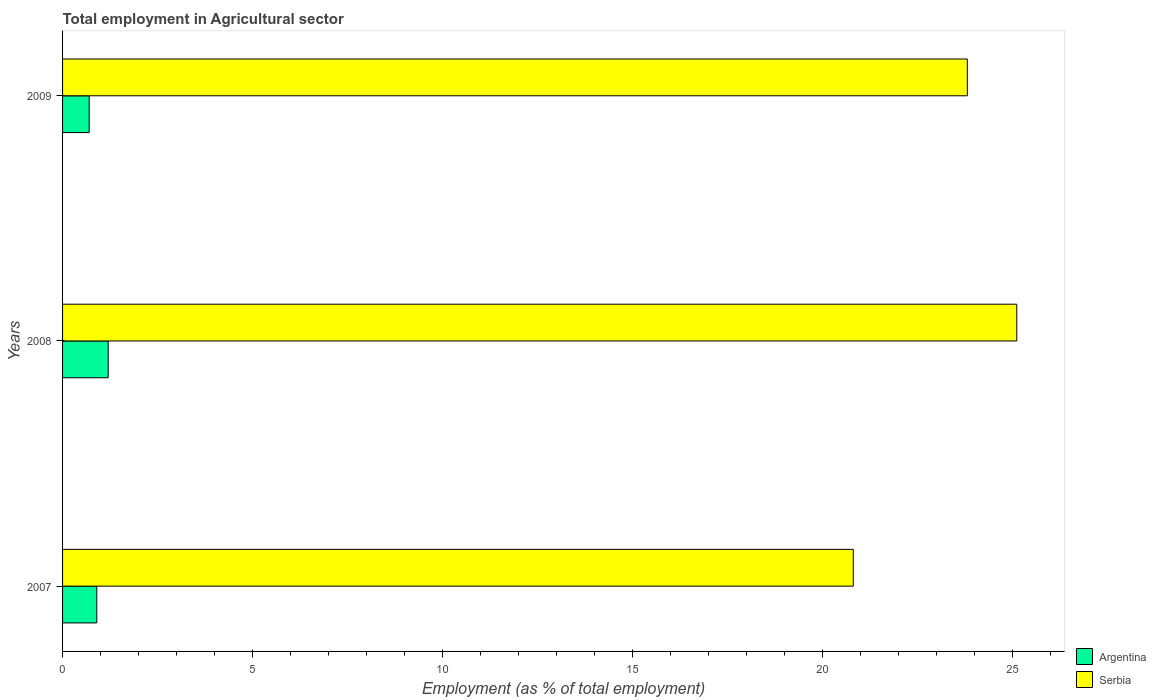How many different coloured bars are there?
Provide a short and direct response. 2. How many groups of bars are there?
Your answer should be compact. 3. How many bars are there on the 1st tick from the top?
Offer a very short reply. 2. How many bars are there on the 1st tick from the bottom?
Your response must be concise. 2. In how many cases, is the number of bars for a given year not equal to the number of legend labels?
Provide a succinct answer. 0. What is the employment in agricultural sector in Argentina in 2009?
Provide a short and direct response. 0.7. Across all years, what is the maximum employment in agricultural sector in Serbia?
Your answer should be compact. 25.1. Across all years, what is the minimum employment in agricultural sector in Argentina?
Provide a succinct answer. 0.7. In which year was the employment in agricultural sector in Argentina maximum?
Your answer should be very brief. 2008. What is the total employment in agricultural sector in Argentina in the graph?
Make the answer very short. 2.8. What is the difference between the employment in agricultural sector in Serbia in 2008 and that in 2009?
Give a very brief answer. 1.3. What is the difference between the employment in agricultural sector in Serbia in 2008 and the employment in agricultural sector in Argentina in 2007?
Offer a terse response. 24.2. What is the average employment in agricultural sector in Argentina per year?
Keep it short and to the point. 0.93. In the year 2007, what is the difference between the employment in agricultural sector in Serbia and employment in agricultural sector in Argentina?
Your answer should be very brief. 19.9. In how many years, is the employment in agricultural sector in Serbia greater than 6 %?
Provide a succinct answer. 3. What is the ratio of the employment in agricultural sector in Argentina in 2008 to that in 2009?
Your response must be concise. 1.71. Is the employment in agricultural sector in Serbia in 2007 less than that in 2009?
Your answer should be very brief. Yes. What is the difference between the highest and the second highest employment in agricultural sector in Argentina?
Your answer should be very brief. 0.3. What is the difference between the highest and the lowest employment in agricultural sector in Argentina?
Your answer should be very brief. 0.5. Is the sum of the employment in agricultural sector in Serbia in 2007 and 2009 greater than the maximum employment in agricultural sector in Argentina across all years?
Offer a very short reply. Yes. What does the 1st bar from the top in 2008 represents?
Give a very brief answer. Serbia. What does the 1st bar from the bottom in 2007 represents?
Make the answer very short. Argentina. How many years are there in the graph?
Your answer should be very brief. 3. What is the difference between two consecutive major ticks on the X-axis?
Your answer should be very brief. 5. Does the graph contain grids?
Provide a succinct answer. No. What is the title of the graph?
Give a very brief answer. Total employment in Agricultural sector. Does "Finland" appear as one of the legend labels in the graph?
Provide a short and direct response. No. What is the label or title of the X-axis?
Provide a succinct answer. Employment (as % of total employment). What is the Employment (as % of total employment) in Argentina in 2007?
Make the answer very short. 0.9. What is the Employment (as % of total employment) of Serbia in 2007?
Keep it short and to the point. 20.8. What is the Employment (as % of total employment) of Argentina in 2008?
Keep it short and to the point. 1.2. What is the Employment (as % of total employment) of Serbia in 2008?
Provide a succinct answer. 25.1. What is the Employment (as % of total employment) in Argentina in 2009?
Offer a terse response. 0.7. What is the Employment (as % of total employment) of Serbia in 2009?
Offer a very short reply. 23.8. Across all years, what is the maximum Employment (as % of total employment) of Argentina?
Make the answer very short. 1.2. Across all years, what is the maximum Employment (as % of total employment) of Serbia?
Give a very brief answer. 25.1. Across all years, what is the minimum Employment (as % of total employment) of Argentina?
Ensure brevity in your answer.  0.7. Across all years, what is the minimum Employment (as % of total employment) of Serbia?
Give a very brief answer. 20.8. What is the total Employment (as % of total employment) in Argentina in the graph?
Keep it short and to the point. 2.8. What is the total Employment (as % of total employment) in Serbia in the graph?
Ensure brevity in your answer.  69.7. What is the difference between the Employment (as % of total employment) of Argentina in 2007 and that in 2008?
Give a very brief answer. -0.3. What is the difference between the Employment (as % of total employment) in Serbia in 2007 and that in 2008?
Keep it short and to the point. -4.3. What is the difference between the Employment (as % of total employment) in Argentina in 2007 and that in 2009?
Provide a short and direct response. 0.2. What is the difference between the Employment (as % of total employment) of Argentina in 2007 and the Employment (as % of total employment) of Serbia in 2008?
Make the answer very short. -24.2. What is the difference between the Employment (as % of total employment) of Argentina in 2007 and the Employment (as % of total employment) of Serbia in 2009?
Your answer should be compact. -22.9. What is the difference between the Employment (as % of total employment) in Argentina in 2008 and the Employment (as % of total employment) in Serbia in 2009?
Make the answer very short. -22.6. What is the average Employment (as % of total employment) of Serbia per year?
Keep it short and to the point. 23.23. In the year 2007, what is the difference between the Employment (as % of total employment) of Argentina and Employment (as % of total employment) of Serbia?
Your answer should be compact. -19.9. In the year 2008, what is the difference between the Employment (as % of total employment) in Argentina and Employment (as % of total employment) in Serbia?
Keep it short and to the point. -23.9. In the year 2009, what is the difference between the Employment (as % of total employment) in Argentina and Employment (as % of total employment) in Serbia?
Give a very brief answer. -23.1. What is the ratio of the Employment (as % of total employment) in Serbia in 2007 to that in 2008?
Offer a very short reply. 0.83. What is the ratio of the Employment (as % of total employment) in Argentina in 2007 to that in 2009?
Keep it short and to the point. 1.29. What is the ratio of the Employment (as % of total employment) in Serbia in 2007 to that in 2009?
Provide a succinct answer. 0.87. What is the ratio of the Employment (as % of total employment) of Argentina in 2008 to that in 2009?
Keep it short and to the point. 1.71. What is the ratio of the Employment (as % of total employment) of Serbia in 2008 to that in 2009?
Provide a succinct answer. 1.05. What is the difference between the highest and the second highest Employment (as % of total employment) in Serbia?
Keep it short and to the point. 1.3. What is the difference between the highest and the lowest Employment (as % of total employment) of Argentina?
Provide a succinct answer. 0.5. What is the difference between the highest and the lowest Employment (as % of total employment) of Serbia?
Your answer should be compact. 4.3. 